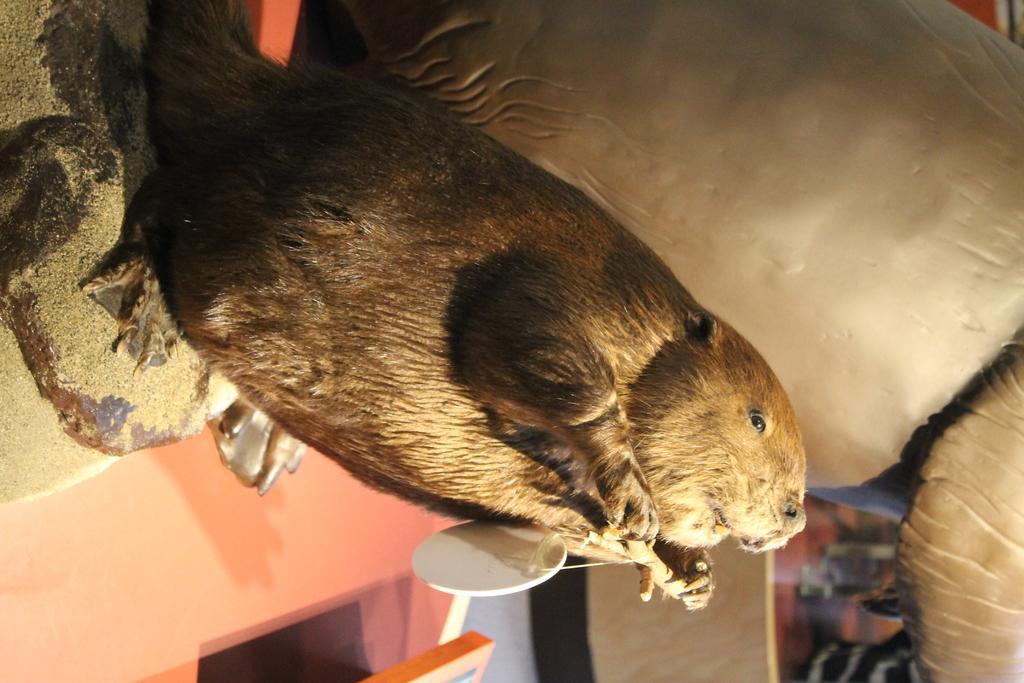Please provide a concise description of this image. In this image there is a mice statue on top of a table, beside the statue there is an object. 